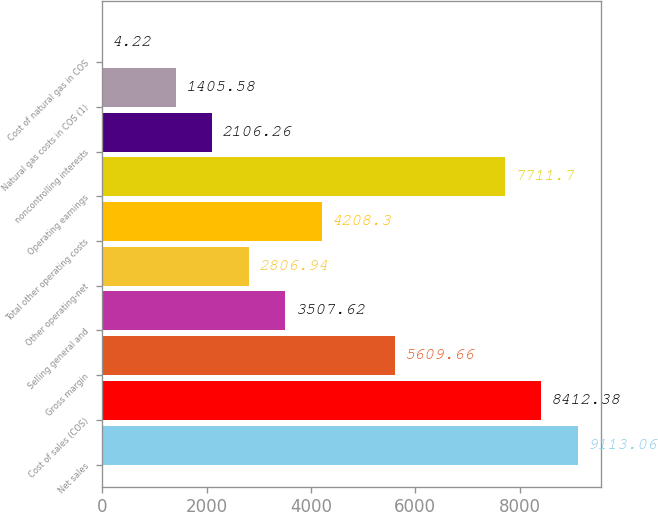Convert chart. <chart><loc_0><loc_0><loc_500><loc_500><bar_chart><fcel>Net sales<fcel>Cost of sales (COS)<fcel>Gross margin<fcel>Selling general and<fcel>Other operating-net<fcel>Total other operating costs<fcel>Operating earnings<fcel>noncontrolling interests<fcel>Natural gas costs in COS (1)<fcel>Cost of natural gas in COS<nl><fcel>9113.06<fcel>8412.38<fcel>5609.66<fcel>3507.62<fcel>2806.94<fcel>4208.3<fcel>7711.7<fcel>2106.26<fcel>1405.58<fcel>4.22<nl></chart> 